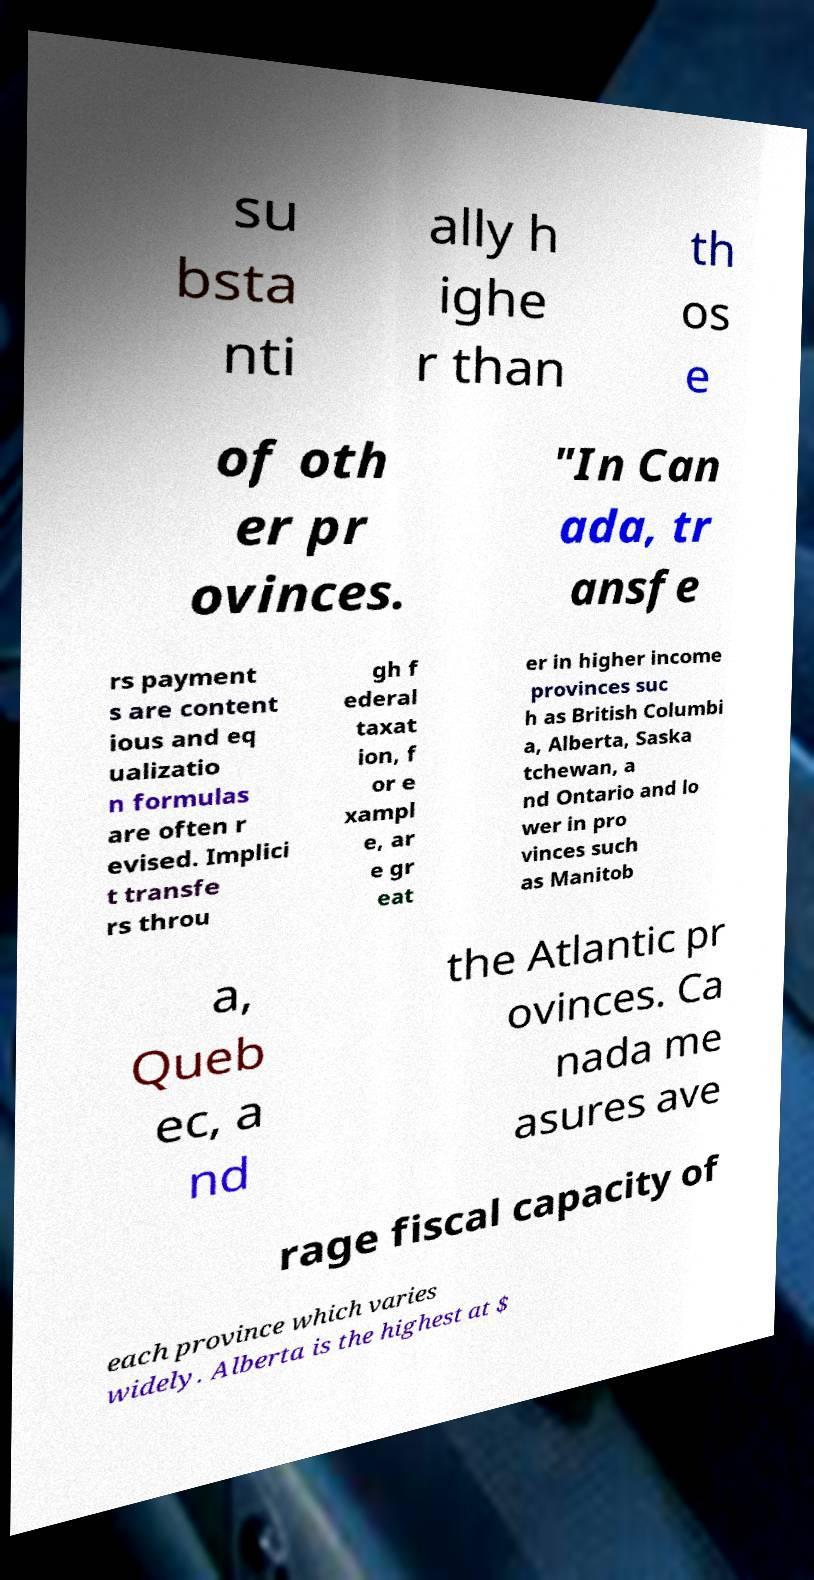I need the written content from this picture converted into text. Can you do that? su bsta nti ally h ighe r than th os e of oth er pr ovinces. "In Can ada, tr ansfe rs payment s are content ious and eq ualizatio n formulas are often r evised. Implici t transfe rs throu gh f ederal taxat ion, f or e xampl e, ar e gr eat er in higher income provinces suc h as British Columbi a, Alberta, Saska tchewan, a nd Ontario and lo wer in pro vinces such as Manitob a, Queb ec, a nd the Atlantic pr ovinces. Ca nada me asures ave rage fiscal capacity of each province which varies widely. Alberta is the highest at $ 